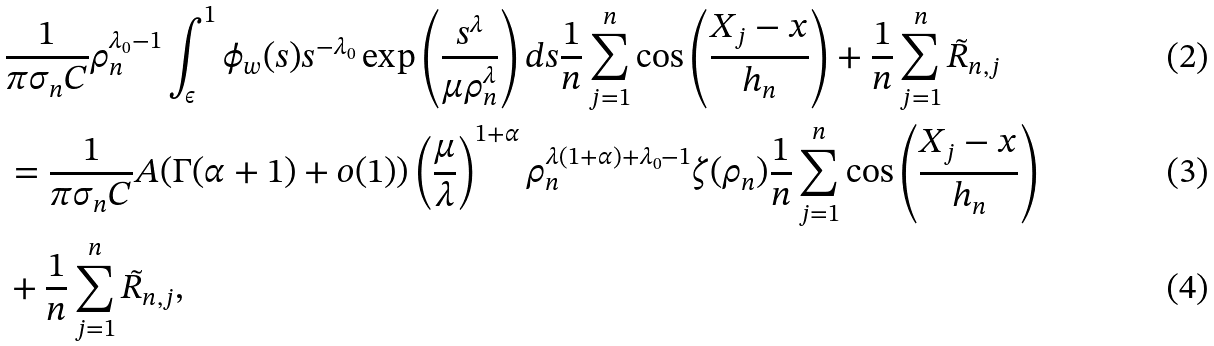Convert formula to latex. <formula><loc_0><loc_0><loc_500><loc_500>& \frac { 1 } { \pi \sigma _ { n } C } \rho _ { n } ^ { \lambda _ { 0 } - 1 } \int _ { \epsilon } ^ { 1 } \phi _ { w } ( s ) s ^ { - \lambda _ { 0 } } \exp \left ( \frac { s ^ { \lambda } } { \mu \rho _ { n } ^ { \lambda } } \right ) d s \frac { 1 } { n } \sum _ { j = 1 } ^ { n } \cos \left ( \frac { X _ { j } - x } { h _ { n } } \right ) + \frac { 1 } { n } \sum _ { j = 1 } ^ { n } \tilde { R } _ { n , j } \\ & = \frac { 1 } { \pi \sigma _ { n } C } A ( \Gamma ( \alpha + 1 ) + o ( 1 ) ) \left ( \frac { \mu } { \lambda } \right ) ^ { 1 + \alpha } \rho _ { n } ^ { \lambda ( 1 + \alpha ) + \lambda _ { 0 } - 1 } \zeta ( \rho _ { n } ) \frac { 1 } { n } \sum _ { j = 1 } ^ { n } \cos \left ( \frac { X _ { j } - x } { h _ { n } } \right ) \\ & + \frac { 1 } { n } \sum _ { j = 1 } ^ { n } \tilde { R } _ { n , j } ,</formula> 